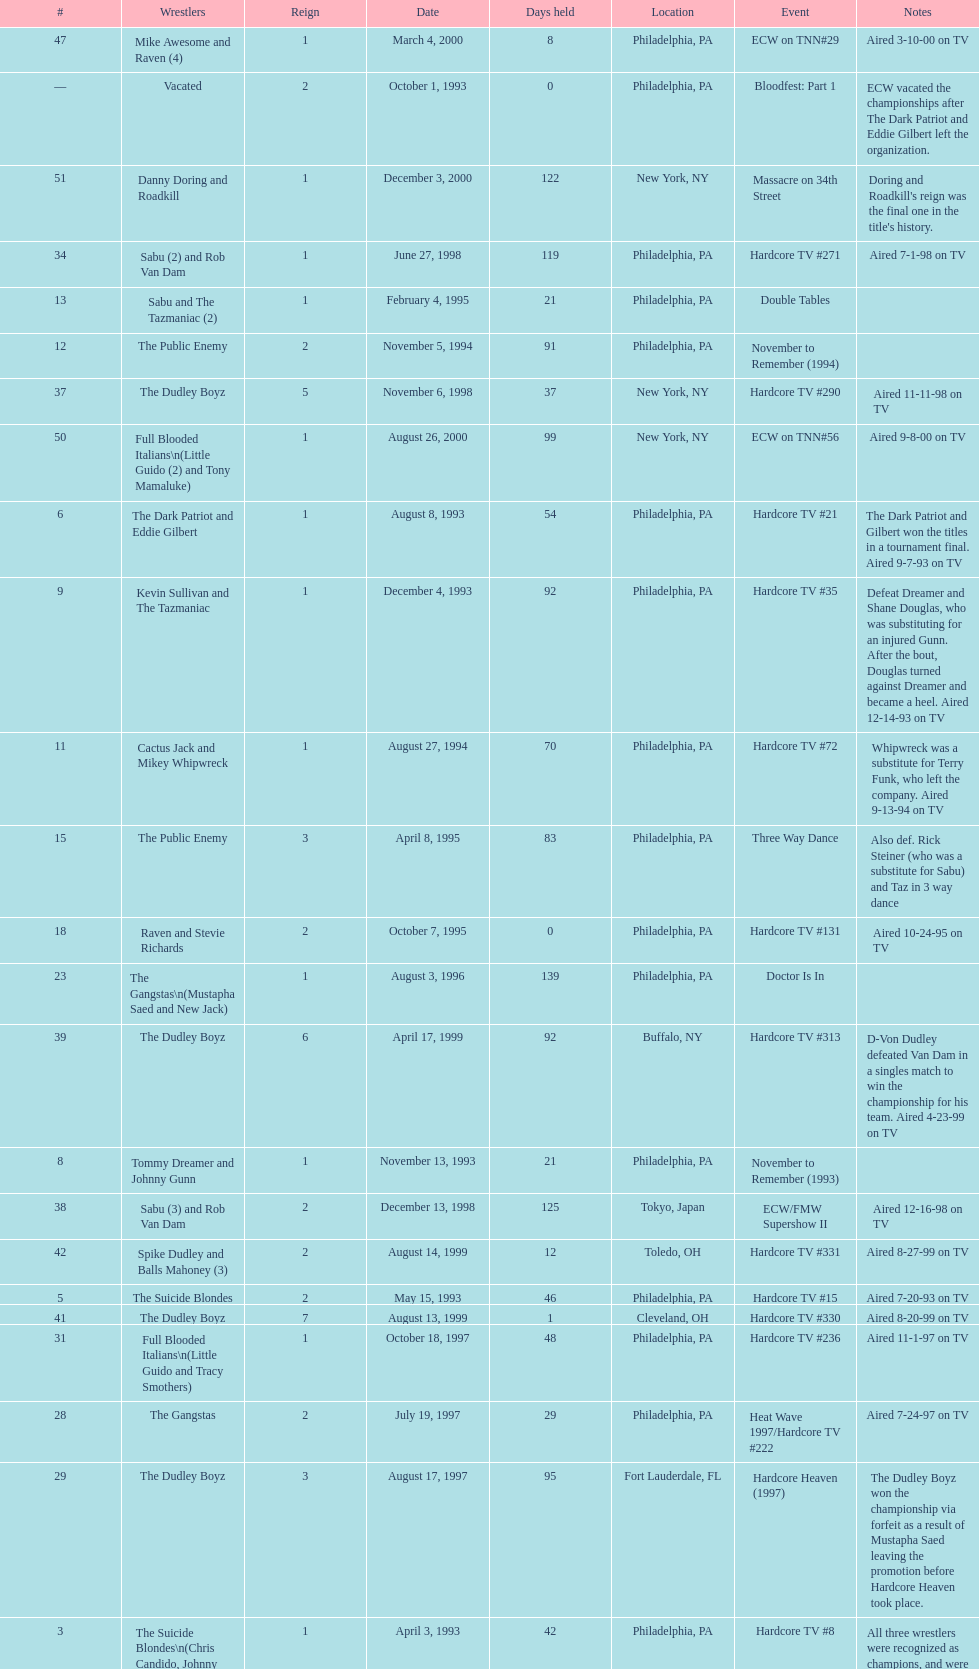Can you give me this table as a dict? {'header': ['#', 'Wrestlers', 'Reign', 'Date', 'Days held', 'Location', 'Event', 'Notes'], 'rows': [['47', 'Mike Awesome and Raven (4)', '1', 'March 4, 2000', '8', 'Philadelphia, PA', 'ECW on TNN#29', 'Aired 3-10-00 on TV'], ['—', 'Vacated', '2', 'October 1, 1993', '0', 'Philadelphia, PA', 'Bloodfest: Part 1', 'ECW vacated the championships after The Dark Patriot and Eddie Gilbert left the organization.'], ['51', 'Danny Doring and Roadkill', '1', 'December 3, 2000', '122', 'New York, NY', 'Massacre on 34th Street', "Doring and Roadkill's reign was the final one in the title's history."], ['34', 'Sabu (2) and Rob Van Dam', '1', 'June 27, 1998', '119', 'Philadelphia, PA', 'Hardcore TV #271', 'Aired 7-1-98 on TV'], ['13', 'Sabu and The Tazmaniac (2)', '1', 'February 4, 1995', '21', 'Philadelphia, PA', 'Double Tables', ''], ['12', 'The Public Enemy', '2', 'November 5, 1994', '91', 'Philadelphia, PA', 'November to Remember (1994)', ''], ['37', 'The Dudley Boyz', '5', 'November 6, 1998', '37', 'New York, NY', 'Hardcore TV #290', 'Aired 11-11-98 on TV'], ['50', 'Full Blooded Italians\\n(Little Guido (2) and Tony Mamaluke)', '1', 'August 26, 2000', '99', 'New York, NY', 'ECW on TNN#56', 'Aired 9-8-00 on TV'], ['6', 'The Dark Patriot and Eddie Gilbert', '1', 'August 8, 1993', '54', 'Philadelphia, PA', 'Hardcore TV #21', 'The Dark Patriot and Gilbert won the titles in a tournament final. Aired 9-7-93 on TV'], ['9', 'Kevin Sullivan and The Tazmaniac', '1', 'December 4, 1993', '92', 'Philadelphia, PA', 'Hardcore TV #35', 'Defeat Dreamer and Shane Douglas, who was substituting for an injured Gunn. After the bout, Douglas turned against Dreamer and became a heel. Aired 12-14-93 on TV'], ['11', 'Cactus Jack and Mikey Whipwreck', '1', 'August 27, 1994', '70', 'Philadelphia, PA', 'Hardcore TV #72', 'Whipwreck was a substitute for Terry Funk, who left the company. Aired 9-13-94 on TV'], ['15', 'The Public Enemy', '3', 'April 8, 1995', '83', 'Philadelphia, PA', 'Three Way Dance', 'Also def. Rick Steiner (who was a substitute for Sabu) and Taz in 3 way dance'], ['18', 'Raven and Stevie Richards', '2', 'October 7, 1995', '0', 'Philadelphia, PA', 'Hardcore TV #131', 'Aired 10-24-95 on TV'], ['23', 'The Gangstas\\n(Mustapha Saed and New Jack)', '1', 'August 3, 1996', '139', 'Philadelphia, PA', 'Doctor Is In', ''], ['39', 'The Dudley Boyz', '6', 'April 17, 1999', '92', 'Buffalo, NY', 'Hardcore TV #313', 'D-Von Dudley defeated Van Dam in a singles match to win the championship for his team. Aired 4-23-99 on TV'], ['8', 'Tommy Dreamer and Johnny Gunn', '1', 'November 13, 1993', '21', 'Philadelphia, PA', 'November to Remember (1993)', ''], ['38', 'Sabu (3) and Rob Van Dam', '2', 'December 13, 1998', '125', 'Tokyo, Japan', 'ECW/FMW Supershow II', 'Aired 12-16-98 on TV'], ['42', 'Spike Dudley and Balls Mahoney (3)', '2', 'August 14, 1999', '12', 'Toledo, OH', 'Hardcore TV #331', 'Aired 8-27-99 on TV'], ['5', 'The Suicide Blondes', '2', 'May 15, 1993', '46', 'Philadelphia, PA', 'Hardcore TV #15', 'Aired 7-20-93 on TV'], ['41', 'The Dudley Boyz', '7', 'August 13, 1999', '1', 'Cleveland, OH', 'Hardcore TV #330', 'Aired 8-20-99 on TV'], ['31', 'Full Blooded Italians\\n(Little Guido and Tracy Smothers)', '1', 'October 18, 1997', '48', 'Philadelphia, PA', 'Hardcore TV #236', 'Aired 11-1-97 on TV'], ['28', 'The Gangstas', '2', 'July 19, 1997', '29', 'Philadelphia, PA', 'Heat Wave 1997/Hardcore TV #222', 'Aired 7-24-97 on TV'], ['29', 'The Dudley Boyz', '3', 'August 17, 1997', '95', 'Fort Lauderdale, FL', 'Hardcore Heaven (1997)', 'The Dudley Boyz won the championship via forfeit as a result of Mustapha Saed leaving the promotion before Hardcore Heaven took place.'], ['3', 'The Suicide Blondes\\n(Chris Candido, Johnny Hotbody, and Chris Michaels)', '1', 'April 3, 1993', '42', 'Philadelphia, PA', 'Hardcore TV #8', 'All three wrestlers were recognized as champions, and were able to defend the titles in any combination via the Freebird rule. Aired 5-25-93 on TV'], ['1', 'The Super Destroyers\\n(A.J. Petrucci and Doug Stahl)', '1', 'June 23, 1992', '283', 'Philadelphia, PA', 'Live event', 'Petrucci and Stahl won the titles in a tournament final.'], ['24', 'The Eliminators', '2', 'December 20, 1996', '85', 'Middletown, NY', 'Hardcore TV #193', 'Aired on 12/31/96 on Hardcore TV'], ['—', 'Vacated', '3', 'April 22, 2000', '125', 'Philadelphia, PA', 'Live event', 'At CyberSlam, Justin Credible threw down the titles to become eligible for the ECW World Heavyweight Championship. Storm later left for World Championship Wrestling. As a result of the circumstances, Credible vacated the championship.'], ['—', 'Vacated', '1', 'July 1993', '39', 'N/A', 'N/A', 'ECW vacated the title after Candido left the promotion for the Smoky Mountain Wrestling organization.'], ['49', 'Yoshihiro Tajiri and Mikey Whipwreck (3)', '1', 'August 25, 2000', '1', 'New York, NY', 'ECW on TNN#55', 'Aired 9-1-00 on TV'], ['20', '2 Cold Scorpio and The Sandman', '1', 'October 28, 1995', '62', 'Philadelphia, PA', 'Hardcore TV #133', 'Scorpio defeats Rocco Rock in a singles bout and wins the tag team title, choosing Sandman as his partner. Aired 11-7-95 on TV'], ['45', 'Impact Players\\n(Justin Credible and Lance Storm (2))', '1', 'January 9, 2000', '48', 'Birmingham, AL', 'Guilty as Charged (2000)', ''], ['33', 'Chris Candido (3) and Lance Storm', '1', 'December 6, 1997', '203', 'Philadelphia, PA', 'Better than Ever', ''], ['14', 'Chris Benoit and Dean Malenko', '1', 'February 25, 1995', '42', 'Philadelphia, PA', 'Return of the Funker', ''], ['32', 'Doug Furnas and Phil LaFon', '1', 'December 5, 1997', '1', 'Waltham, MA', 'Live event', ''], ['7', 'Johnny Hotbody (3) and Tony Stetson (2)', '1', 'October 1, 1993', '43', 'Philadelphia, PA', 'Bloodfest: Part 1', 'Hotbody and Stetson were awarded the titles by ECW.'], ['43', 'The Dudley Boyz', '8', 'August 26, 1999', '0', 'New York, NY', 'ECW on TNN#2', 'Aired 9-3-99 on TV'], ['44', 'Tommy Dreamer (2) and Raven (3)', '1', 'August 26, 1999', '136', 'New York, NY', 'ECW on TNN#2', 'Aired 9-3-99 on TV'], ['36', 'Balls Mahoney and Masato Tanaka', '1', 'November 1, 1998', '5', 'New Orleans, LA', 'November to Remember (1998)', ''], ['19', 'The Public Enemy', '4', 'October 7, 1995', '21', 'Philadelphia, PA', 'Hardcore TV #131', 'Aired 10-24-95 on TV'], ['26', 'The Eliminators', '3', 'April 13, 1997', '68', 'Philadelphia, PA', 'Barely Legal', ''], ['16', 'Raven and Stevie Richards', '1', 'June 30, 1995', '78', 'Jim Thorpe, PA', 'Hardcore TV #115', 'Aired 7-4-95 on TV'], ['27', 'The Dudley Boyz', '2', 'June 20, 1997', '29', 'Waltham, MA', 'Hardcore TV #218', 'The Dudley Boyz defeated Kronus in a handicap match as a result of a sidelining injury sustained by Saturn. Aired 6-26-97 on TV'], ['48', 'Impact Players\\n(Justin Credible and Lance Storm (3))', '2', 'March 12, 2000', '31', 'Danbury, CT', 'Living Dangerously', ''], ['30', 'The Gangstanators\\n(Kronus (4) and New Jack (3))', '1', 'September 20, 1997', '28', 'Philadelphia, PA', 'As Good as it Gets', 'Aired 9-27-97 on TV'], ['35', 'The Dudley Boyz', '4', 'October 24, 1998', '8', 'Cleveland, OH', 'Hardcore TV #288', 'Aired 10-28-98 on TV'], ['4', 'The Super Destroyers', '2', 'May 15, 1993', '0', 'Philadelphia, PA', 'Hardcore TV #14', 'Aired 7-6-93 on TV'], ['2', 'Tony Stetson and Larry Winters', '1', 'April 2, 1993', '1', 'Radnor, PA', 'Hardcore TV #6', 'Aired 5-11-93 on TV'], ['22', 'The Eliminators\\n(Kronus and Saturn)', '1', 'February 3, 1996', '182', 'New York, NY', 'Big Apple Blizzard Blast', ''], ['25', 'The Dudley Boyz\\n(Buh Buh Ray Dudley and D-Von Dudley)', '1', 'March 15, 1997', '29', 'Philadelphia, PA', 'Hostile City Showdown', 'Aired 3/20/97 on Hardcore TV'], ['40', 'Spike Dudley and Balls Mahoney (2)', '1', 'July 18, 1999', '26', 'Dayton, OH', 'Heat Wave (1999)', ''], ['21', 'Cactus Jack and Mikey Whipwreck', '2', 'December 29, 1995', '36', 'New York, NY', 'Holiday Hell 1995', "Whipwreck defeated 2 Cold Scorpio in a singles match to win both the tag team titles and the ECW World Television Championship; Cactus Jack came out and declared himself to be Mikey's partner after he won the match."], ['17', 'The Pitbulls\\n(Pitbull #1 and Pitbull #2)', '1', 'September 16, 1995', '21', 'Philadelphia, PA', "Gangsta's Paradise", ''], ['10', 'The Public Enemy\\n(Johnny Grunge and Rocco Rock)', '1', 'March 6, 1994', '174', 'Philadelphia, PA', 'Hardcore TV #46', 'Aired 3-8-94 on TV'], ['46', 'Tommy Dreamer (3) and Masato Tanaka (2)', '1', 'February 26, 2000', '7', 'Cincinnati, OH', 'Hardcore TV #358', 'Aired 3-7-00 on TV']]} What event comes before hardcore tv #14? Hardcore TV #8. 